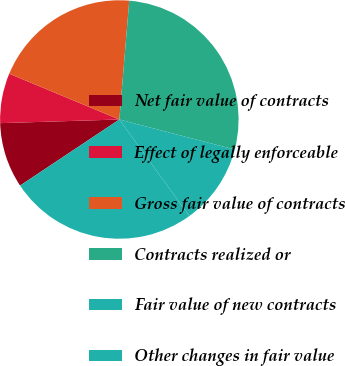Convert chart. <chart><loc_0><loc_0><loc_500><loc_500><pie_chart><fcel>Net fair value of contracts<fcel>Effect of legally enforceable<fcel>Gross fair value of contracts<fcel>Contracts realized or<fcel>Fair value of new contracts<fcel>Other changes in fair value<nl><fcel>8.86%<fcel>6.76%<fcel>20.05%<fcel>27.73%<fcel>10.96%<fcel>25.63%<nl></chart> 